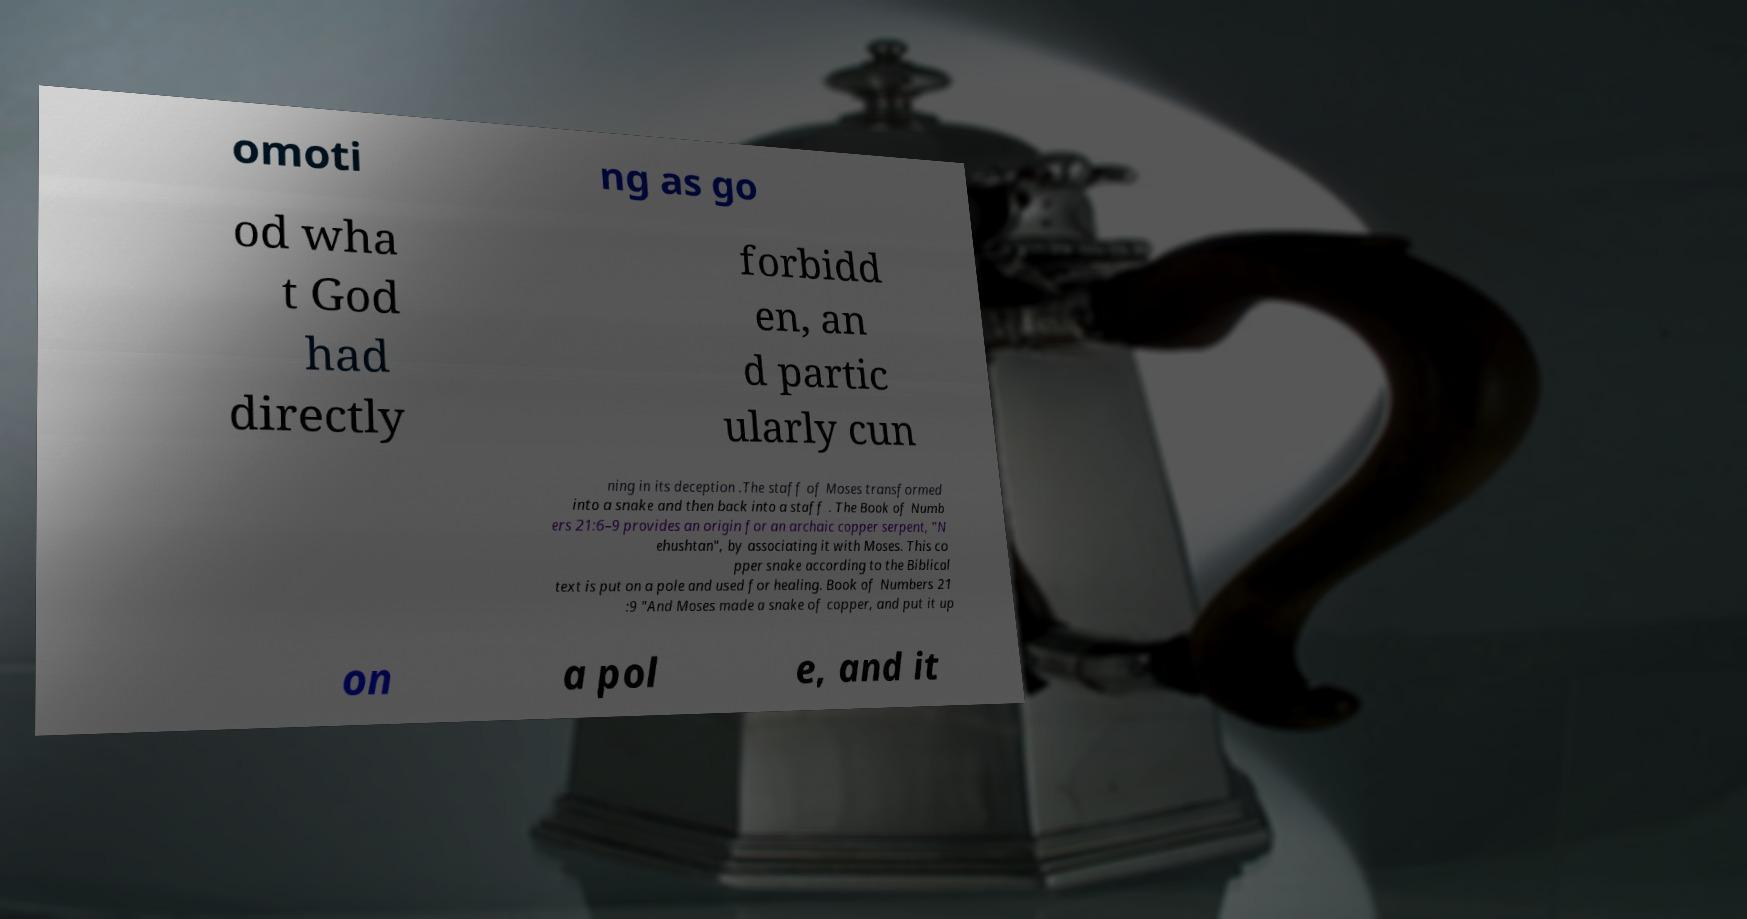Could you assist in decoding the text presented in this image and type it out clearly? omoti ng as go od wha t God had directly forbidd en, an d partic ularly cun ning in its deception .The staff of Moses transformed into a snake and then back into a staff . The Book of Numb ers 21:6–9 provides an origin for an archaic copper serpent, "N ehushtan", by associating it with Moses. This co pper snake according to the Biblical text is put on a pole and used for healing. Book of Numbers 21 :9 "And Moses made a snake of copper, and put it up on a pol e, and it 